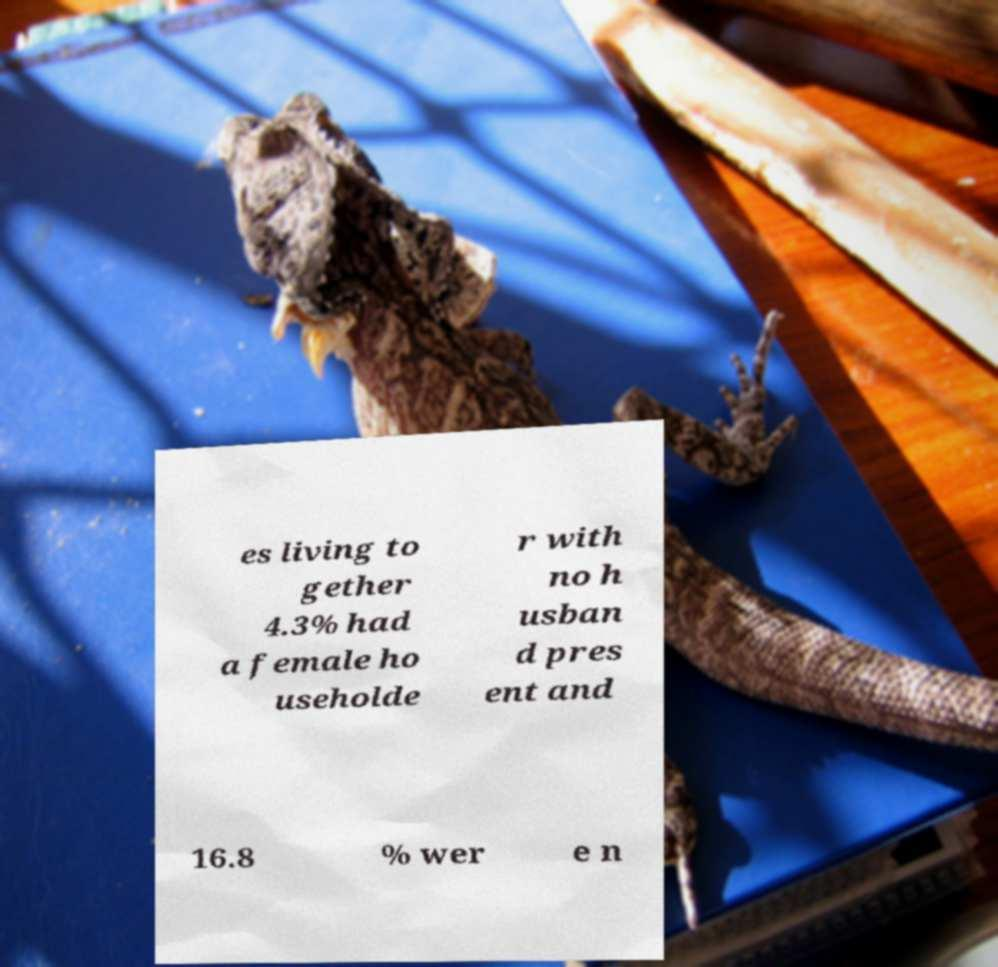Could you assist in decoding the text presented in this image and type it out clearly? es living to gether 4.3% had a female ho useholde r with no h usban d pres ent and 16.8 % wer e n 